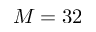<formula> <loc_0><loc_0><loc_500><loc_500>M = 3 2</formula> 